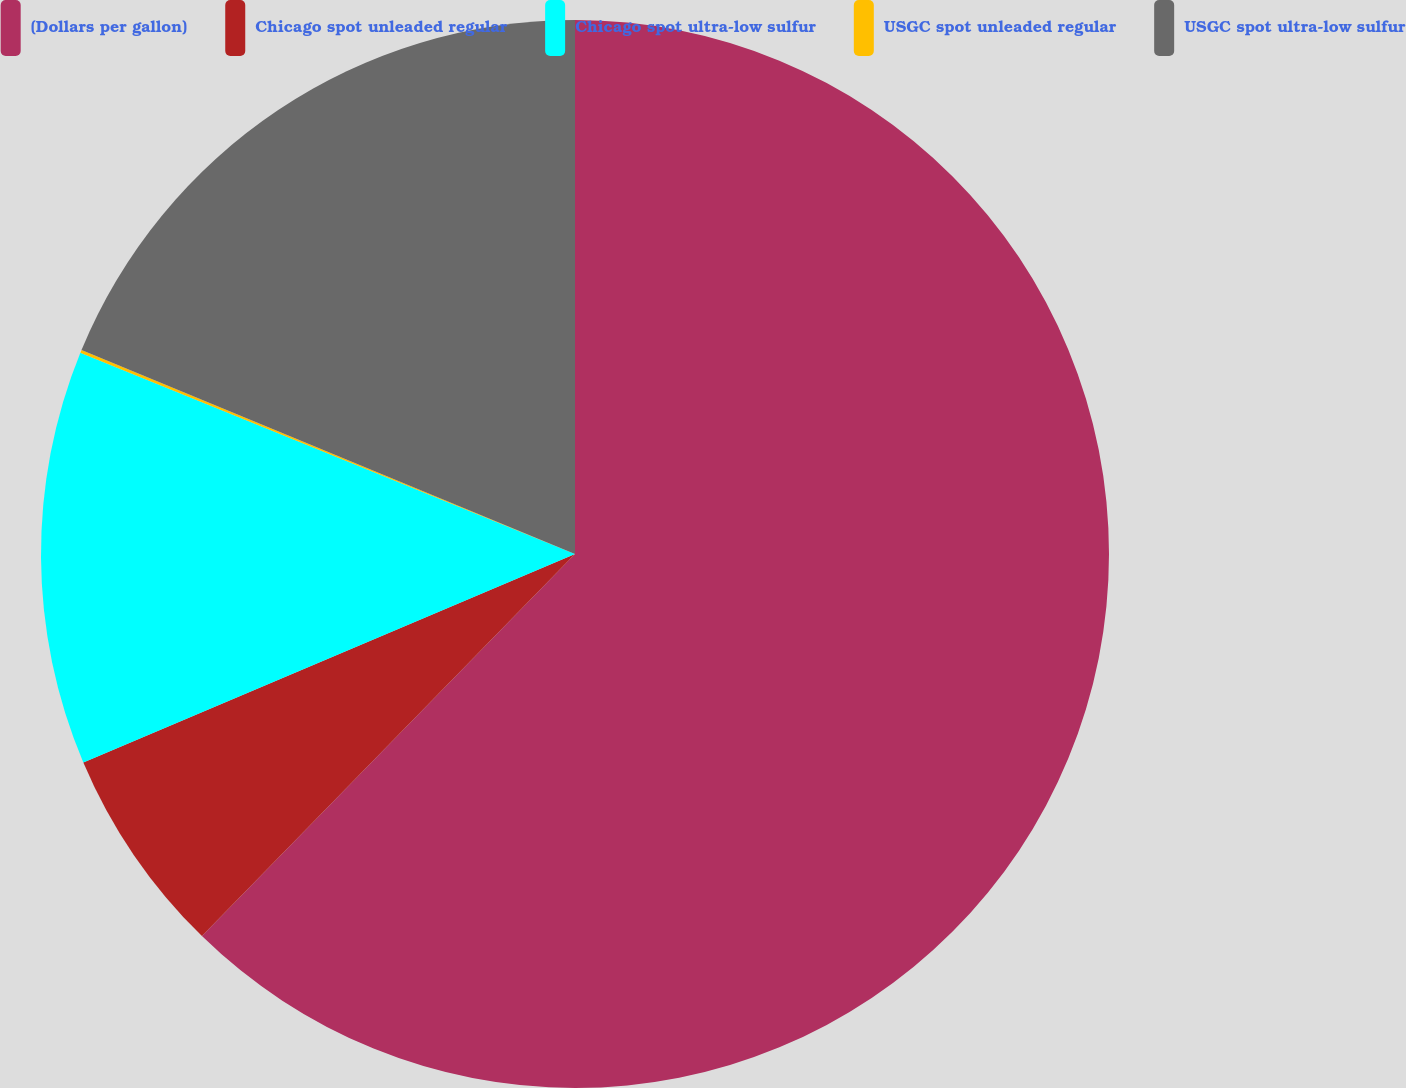<chart> <loc_0><loc_0><loc_500><loc_500><pie_chart><fcel>(Dollars per gallon)<fcel>Chicago spot unleaded regular<fcel>Chicago spot ultra-low sulfur<fcel>USGC spot unleaded regular<fcel>USGC spot ultra-low sulfur<nl><fcel>62.31%<fcel>6.31%<fcel>12.53%<fcel>0.09%<fcel>18.76%<nl></chart> 